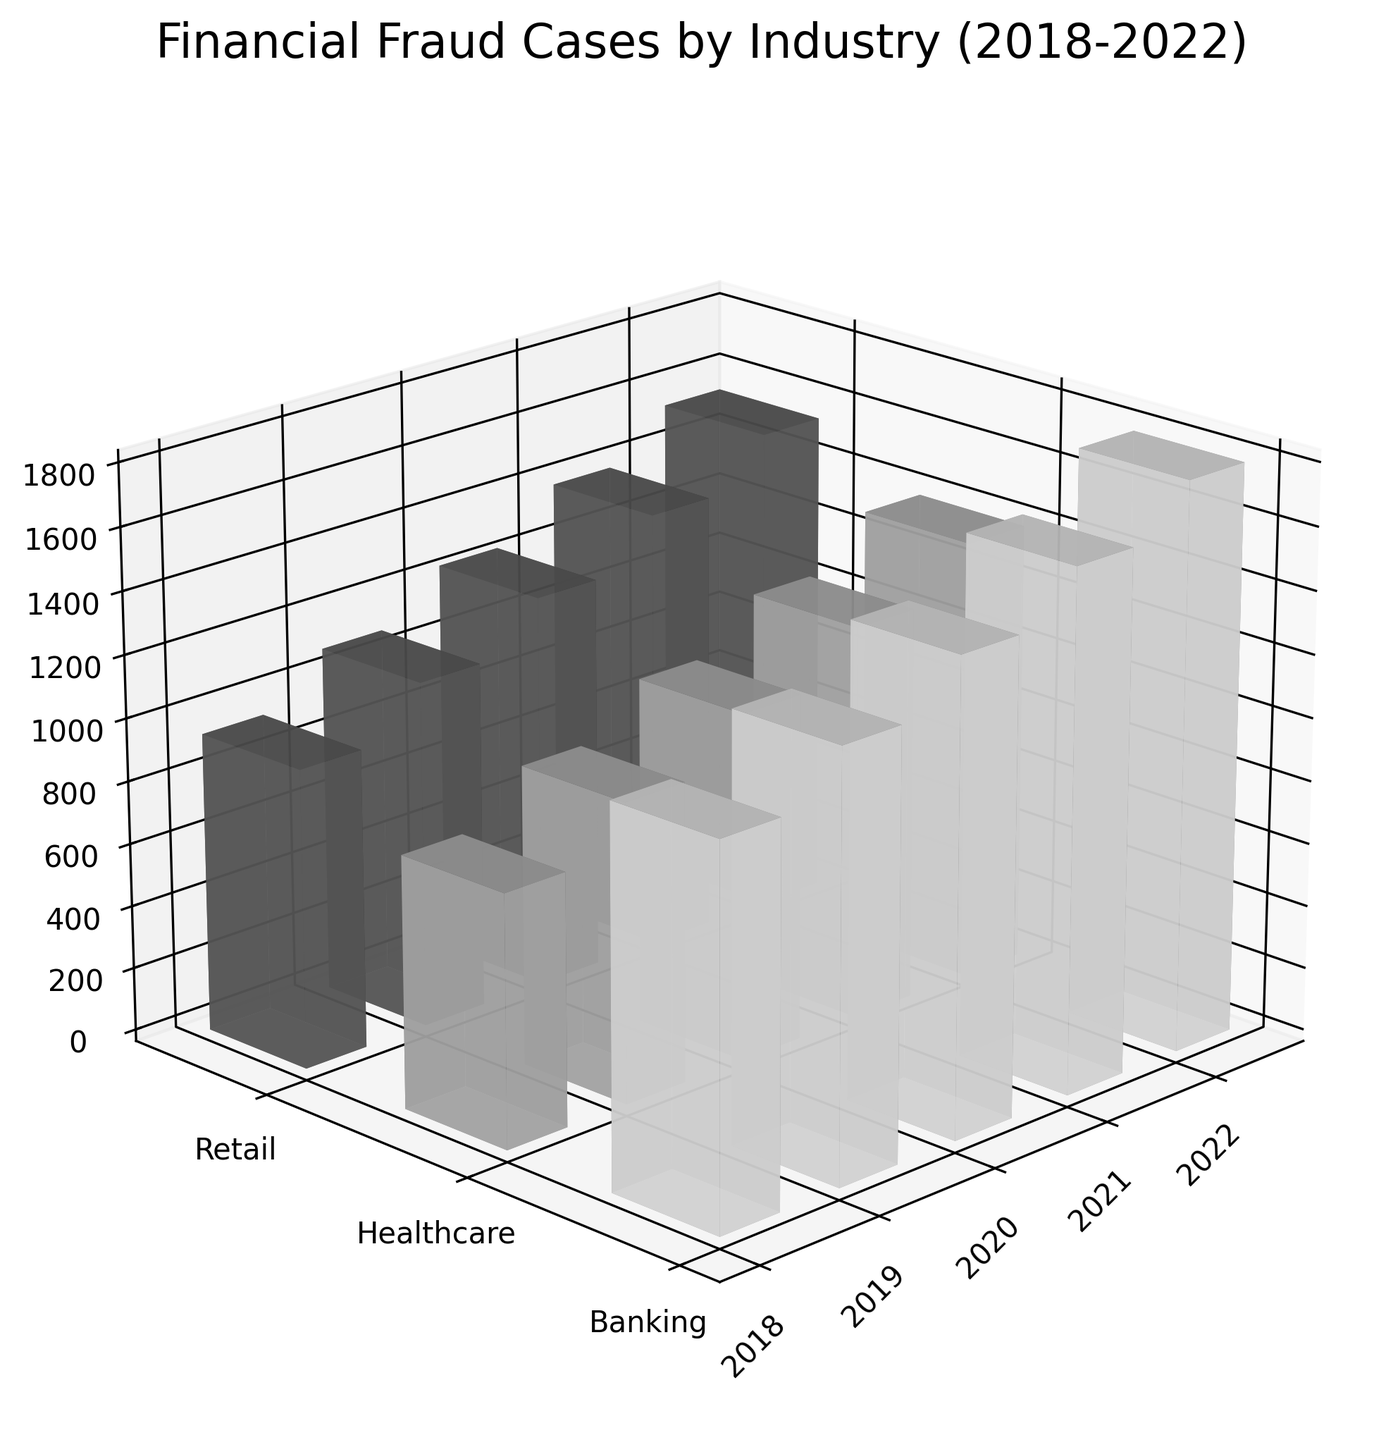What is the title of the 3D plot? The title of the plot is located at the top and provides a summary of what the plot shows. By looking at the top of the plot, we can see the title: "Financial Fraud Cases by Industry (2018-2022)."
Answer: Financial Fraud Cases by Industry (2018-2022) What does the z-axis represent? The z-axis label found along the vertical line of the 3D plot indicates what the axis measures. It shows "Number of Cases."
Answer: Number of Cases Which industry had the most fraud cases in 2020? To find this, identify the highest bar in the year 2020 across the three industries. The tallest bar in 2020 corresponds to the Banking industry.
Answer: Banking How do the number of fraud cases in Healthcare change from 2018 to 2022? Observe the bars for the Healthcare industry from 2018 to 2022 and look at the height change. The number of cases increases steadily over the years from 800 in 2018 to 1400 in 2022.
Answer: The number of cases increased Which year saw the highest total fraud cases combining all industries? Sum the number of cases for all industries each year and compare. In 2022, the total number of fraud cases across industries is highest (1800 in Banking + 1400 in Healthcare + 1550 in Retail = 4750).
Answer: 2022 Does the Banking industry experience a decrease in fraud cases in any of the years? Check the height of the bars representing Banking from 2018 to 2022. Each year, the number of cases consistently increases.
Answer: No, it doesn't Which two years have the smallest gap in fraud cases for the Retail industry? Compare the heights of Retail bars for each consecutive pair of years and find the pair with the smallest height difference. The years 2019 and 2020 have the smallest gap (1100 to 1250, a difference of 150 cases).
Answer: 2019 and 2020 What is the average number of fraud cases in the Healthcare industry over the five years? Add the number of cases in Healthcare for each year from 2018 to 2022 and divide by 5 (800 + 950 + 1100 + 1250 + 1400 = 5500, then 5500 / 5 = 1100).
Answer: 1100 Which industry had the highest monetary impact of fraud cases in 2022? Compare the monetary impact of fraud cases across industries for 2022. The Banking industry has the highest impact with 1320 million USD.
Answer: Banking 